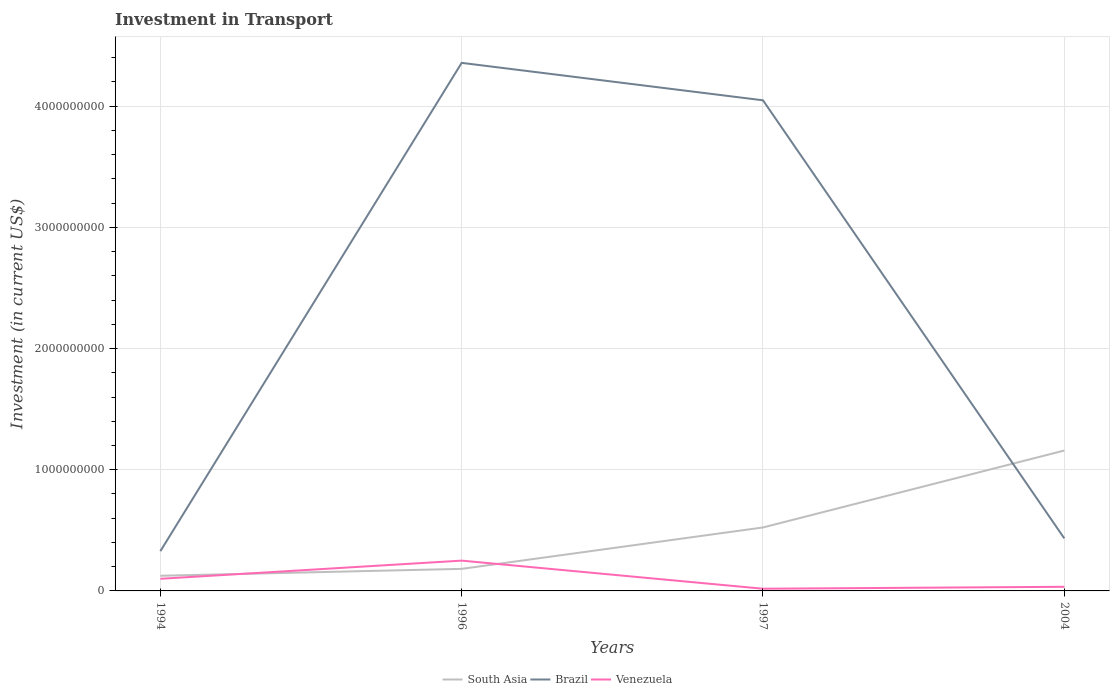Does the line corresponding to Brazil intersect with the line corresponding to Venezuela?
Provide a succinct answer. No. Across all years, what is the maximum amount invested in transport in Brazil?
Your answer should be very brief. 3.28e+08. In which year was the amount invested in transport in South Asia maximum?
Your answer should be very brief. 1994. What is the total amount invested in transport in Brazil in the graph?
Offer a terse response. -4.03e+09. What is the difference between the highest and the second highest amount invested in transport in South Asia?
Your answer should be compact. 1.03e+09. What is the difference between the highest and the lowest amount invested in transport in Brazil?
Offer a very short reply. 2. Is the amount invested in transport in South Asia strictly greater than the amount invested in transport in Brazil over the years?
Your response must be concise. No. How many years are there in the graph?
Keep it short and to the point. 4. Are the values on the major ticks of Y-axis written in scientific E-notation?
Offer a very short reply. No. Does the graph contain any zero values?
Offer a very short reply. No. Does the graph contain grids?
Offer a very short reply. Yes. How are the legend labels stacked?
Your response must be concise. Horizontal. What is the title of the graph?
Provide a short and direct response. Investment in Transport. Does "Kyrgyz Republic" appear as one of the legend labels in the graph?
Provide a short and direct response. No. What is the label or title of the Y-axis?
Offer a terse response. Investment (in current US$). What is the Investment (in current US$) in South Asia in 1994?
Offer a very short reply. 1.25e+08. What is the Investment (in current US$) in Brazil in 1994?
Your answer should be compact. 3.28e+08. What is the Investment (in current US$) in South Asia in 1996?
Your answer should be very brief. 1.82e+08. What is the Investment (in current US$) of Brazil in 1996?
Your answer should be compact. 4.36e+09. What is the Investment (in current US$) in Venezuela in 1996?
Your answer should be very brief. 2.50e+08. What is the Investment (in current US$) of South Asia in 1997?
Make the answer very short. 5.24e+08. What is the Investment (in current US$) of Brazil in 1997?
Your answer should be very brief. 4.05e+09. What is the Investment (in current US$) in Venezuela in 1997?
Your response must be concise. 1.80e+07. What is the Investment (in current US$) of South Asia in 2004?
Offer a terse response. 1.16e+09. What is the Investment (in current US$) in Brazil in 2004?
Provide a succinct answer. 4.34e+08. What is the Investment (in current US$) of Venezuela in 2004?
Keep it short and to the point. 3.40e+07. Across all years, what is the maximum Investment (in current US$) in South Asia?
Make the answer very short. 1.16e+09. Across all years, what is the maximum Investment (in current US$) of Brazil?
Give a very brief answer. 4.36e+09. Across all years, what is the maximum Investment (in current US$) in Venezuela?
Your response must be concise. 2.50e+08. Across all years, what is the minimum Investment (in current US$) in South Asia?
Provide a succinct answer. 1.25e+08. Across all years, what is the minimum Investment (in current US$) of Brazil?
Keep it short and to the point. 3.28e+08. Across all years, what is the minimum Investment (in current US$) of Venezuela?
Offer a terse response. 1.80e+07. What is the total Investment (in current US$) of South Asia in the graph?
Offer a terse response. 1.99e+09. What is the total Investment (in current US$) of Brazil in the graph?
Keep it short and to the point. 9.17e+09. What is the total Investment (in current US$) of Venezuela in the graph?
Offer a terse response. 4.02e+08. What is the difference between the Investment (in current US$) of South Asia in 1994 and that in 1996?
Ensure brevity in your answer.  -5.70e+07. What is the difference between the Investment (in current US$) in Brazil in 1994 and that in 1996?
Give a very brief answer. -4.03e+09. What is the difference between the Investment (in current US$) of Venezuela in 1994 and that in 1996?
Offer a terse response. -1.50e+08. What is the difference between the Investment (in current US$) of South Asia in 1994 and that in 1997?
Offer a very short reply. -3.99e+08. What is the difference between the Investment (in current US$) in Brazil in 1994 and that in 1997?
Offer a terse response. -3.72e+09. What is the difference between the Investment (in current US$) of Venezuela in 1994 and that in 1997?
Provide a short and direct response. 8.20e+07. What is the difference between the Investment (in current US$) in South Asia in 1994 and that in 2004?
Give a very brief answer. -1.03e+09. What is the difference between the Investment (in current US$) of Brazil in 1994 and that in 2004?
Give a very brief answer. -1.06e+08. What is the difference between the Investment (in current US$) in Venezuela in 1994 and that in 2004?
Your answer should be compact. 6.60e+07. What is the difference between the Investment (in current US$) in South Asia in 1996 and that in 1997?
Your answer should be very brief. -3.42e+08. What is the difference between the Investment (in current US$) of Brazil in 1996 and that in 1997?
Your response must be concise. 3.09e+08. What is the difference between the Investment (in current US$) in Venezuela in 1996 and that in 1997?
Give a very brief answer. 2.32e+08. What is the difference between the Investment (in current US$) in South Asia in 1996 and that in 2004?
Offer a terse response. -9.76e+08. What is the difference between the Investment (in current US$) in Brazil in 1996 and that in 2004?
Provide a short and direct response. 3.92e+09. What is the difference between the Investment (in current US$) of Venezuela in 1996 and that in 2004?
Your response must be concise. 2.16e+08. What is the difference between the Investment (in current US$) of South Asia in 1997 and that in 2004?
Offer a terse response. -6.35e+08. What is the difference between the Investment (in current US$) of Brazil in 1997 and that in 2004?
Keep it short and to the point. 3.61e+09. What is the difference between the Investment (in current US$) of Venezuela in 1997 and that in 2004?
Keep it short and to the point. -1.60e+07. What is the difference between the Investment (in current US$) of South Asia in 1994 and the Investment (in current US$) of Brazil in 1996?
Your answer should be very brief. -4.23e+09. What is the difference between the Investment (in current US$) in South Asia in 1994 and the Investment (in current US$) in Venezuela in 1996?
Provide a short and direct response. -1.25e+08. What is the difference between the Investment (in current US$) in Brazil in 1994 and the Investment (in current US$) in Venezuela in 1996?
Your response must be concise. 7.81e+07. What is the difference between the Investment (in current US$) in South Asia in 1994 and the Investment (in current US$) in Brazil in 1997?
Offer a very short reply. -3.92e+09. What is the difference between the Investment (in current US$) in South Asia in 1994 and the Investment (in current US$) in Venezuela in 1997?
Offer a very short reply. 1.07e+08. What is the difference between the Investment (in current US$) of Brazil in 1994 and the Investment (in current US$) of Venezuela in 1997?
Your response must be concise. 3.10e+08. What is the difference between the Investment (in current US$) of South Asia in 1994 and the Investment (in current US$) of Brazil in 2004?
Keep it short and to the point. -3.09e+08. What is the difference between the Investment (in current US$) in South Asia in 1994 and the Investment (in current US$) in Venezuela in 2004?
Provide a succinct answer. 9.10e+07. What is the difference between the Investment (in current US$) in Brazil in 1994 and the Investment (in current US$) in Venezuela in 2004?
Your answer should be very brief. 2.94e+08. What is the difference between the Investment (in current US$) of South Asia in 1996 and the Investment (in current US$) of Brazil in 1997?
Keep it short and to the point. -3.87e+09. What is the difference between the Investment (in current US$) in South Asia in 1996 and the Investment (in current US$) in Venezuela in 1997?
Keep it short and to the point. 1.64e+08. What is the difference between the Investment (in current US$) in Brazil in 1996 and the Investment (in current US$) in Venezuela in 1997?
Offer a terse response. 4.34e+09. What is the difference between the Investment (in current US$) in South Asia in 1996 and the Investment (in current US$) in Brazil in 2004?
Your answer should be very brief. -2.52e+08. What is the difference between the Investment (in current US$) in South Asia in 1996 and the Investment (in current US$) in Venezuela in 2004?
Make the answer very short. 1.48e+08. What is the difference between the Investment (in current US$) in Brazil in 1996 and the Investment (in current US$) in Venezuela in 2004?
Your response must be concise. 4.32e+09. What is the difference between the Investment (in current US$) of South Asia in 1997 and the Investment (in current US$) of Brazil in 2004?
Provide a succinct answer. 9.01e+07. What is the difference between the Investment (in current US$) of South Asia in 1997 and the Investment (in current US$) of Venezuela in 2004?
Ensure brevity in your answer.  4.90e+08. What is the difference between the Investment (in current US$) in Brazil in 1997 and the Investment (in current US$) in Venezuela in 2004?
Offer a very short reply. 4.01e+09. What is the average Investment (in current US$) of South Asia per year?
Give a very brief answer. 4.97e+08. What is the average Investment (in current US$) of Brazil per year?
Ensure brevity in your answer.  2.29e+09. What is the average Investment (in current US$) of Venezuela per year?
Give a very brief answer. 1.00e+08. In the year 1994, what is the difference between the Investment (in current US$) of South Asia and Investment (in current US$) of Brazil?
Provide a short and direct response. -2.03e+08. In the year 1994, what is the difference between the Investment (in current US$) of South Asia and Investment (in current US$) of Venezuela?
Your answer should be very brief. 2.50e+07. In the year 1994, what is the difference between the Investment (in current US$) of Brazil and Investment (in current US$) of Venezuela?
Offer a terse response. 2.28e+08. In the year 1996, what is the difference between the Investment (in current US$) in South Asia and Investment (in current US$) in Brazil?
Your answer should be compact. -4.18e+09. In the year 1996, what is the difference between the Investment (in current US$) of South Asia and Investment (in current US$) of Venezuela?
Your answer should be very brief. -6.80e+07. In the year 1996, what is the difference between the Investment (in current US$) in Brazil and Investment (in current US$) in Venezuela?
Offer a very short reply. 4.11e+09. In the year 1997, what is the difference between the Investment (in current US$) of South Asia and Investment (in current US$) of Brazil?
Provide a succinct answer. -3.52e+09. In the year 1997, what is the difference between the Investment (in current US$) in South Asia and Investment (in current US$) in Venezuela?
Offer a very short reply. 5.06e+08. In the year 1997, what is the difference between the Investment (in current US$) of Brazil and Investment (in current US$) of Venezuela?
Ensure brevity in your answer.  4.03e+09. In the year 2004, what is the difference between the Investment (in current US$) of South Asia and Investment (in current US$) of Brazil?
Your answer should be compact. 7.25e+08. In the year 2004, what is the difference between the Investment (in current US$) in South Asia and Investment (in current US$) in Venezuela?
Offer a terse response. 1.12e+09. In the year 2004, what is the difference between the Investment (in current US$) of Brazil and Investment (in current US$) of Venezuela?
Provide a succinct answer. 4.00e+08. What is the ratio of the Investment (in current US$) in South Asia in 1994 to that in 1996?
Give a very brief answer. 0.69. What is the ratio of the Investment (in current US$) in Brazil in 1994 to that in 1996?
Offer a very short reply. 0.08. What is the ratio of the Investment (in current US$) in Venezuela in 1994 to that in 1996?
Offer a terse response. 0.4. What is the ratio of the Investment (in current US$) of South Asia in 1994 to that in 1997?
Offer a very short reply. 0.24. What is the ratio of the Investment (in current US$) in Brazil in 1994 to that in 1997?
Make the answer very short. 0.08. What is the ratio of the Investment (in current US$) in Venezuela in 1994 to that in 1997?
Give a very brief answer. 5.56. What is the ratio of the Investment (in current US$) in South Asia in 1994 to that in 2004?
Your answer should be compact. 0.11. What is the ratio of the Investment (in current US$) in Brazil in 1994 to that in 2004?
Your answer should be compact. 0.76. What is the ratio of the Investment (in current US$) in Venezuela in 1994 to that in 2004?
Keep it short and to the point. 2.94. What is the ratio of the Investment (in current US$) of South Asia in 1996 to that in 1997?
Offer a terse response. 0.35. What is the ratio of the Investment (in current US$) in Brazil in 1996 to that in 1997?
Offer a terse response. 1.08. What is the ratio of the Investment (in current US$) of Venezuela in 1996 to that in 1997?
Give a very brief answer. 13.89. What is the ratio of the Investment (in current US$) of South Asia in 1996 to that in 2004?
Your answer should be compact. 0.16. What is the ratio of the Investment (in current US$) in Brazil in 1996 to that in 2004?
Ensure brevity in your answer.  10.05. What is the ratio of the Investment (in current US$) of Venezuela in 1996 to that in 2004?
Offer a very short reply. 7.35. What is the ratio of the Investment (in current US$) of South Asia in 1997 to that in 2004?
Provide a succinct answer. 0.45. What is the ratio of the Investment (in current US$) in Brazil in 1997 to that in 2004?
Provide a short and direct response. 9.34. What is the ratio of the Investment (in current US$) in Venezuela in 1997 to that in 2004?
Provide a succinct answer. 0.53. What is the difference between the highest and the second highest Investment (in current US$) in South Asia?
Make the answer very short. 6.35e+08. What is the difference between the highest and the second highest Investment (in current US$) of Brazil?
Keep it short and to the point. 3.09e+08. What is the difference between the highest and the second highest Investment (in current US$) of Venezuela?
Ensure brevity in your answer.  1.50e+08. What is the difference between the highest and the lowest Investment (in current US$) of South Asia?
Make the answer very short. 1.03e+09. What is the difference between the highest and the lowest Investment (in current US$) in Brazil?
Your answer should be compact. 4.03e+09. What is the difference between the highest and the lowest Investment (in current US$) in Venezuela?
Offer a terse response. 2.32e+08. 